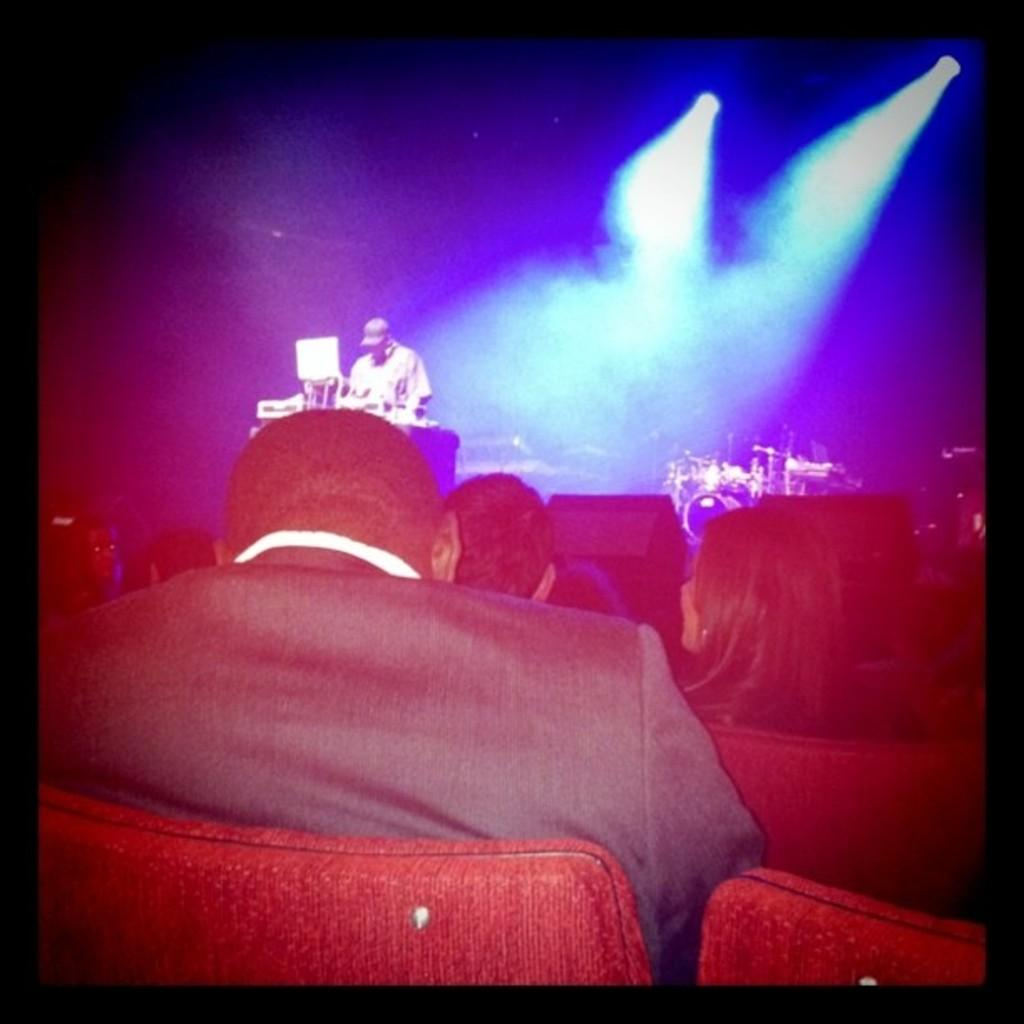What are the people in the image sitting on? The people in the image are sitting on red chairs. What is happening on the stage in the image? A person is standing on a stage in the image. What can be seen on the right side of the image? There are focus lights on the right side of the image. What type of love song is being played by the person on the stage? There is no indication in the image that a love song is being played, as the focus is on the person standing on the stage and the presence of red chairs and focus lights. 